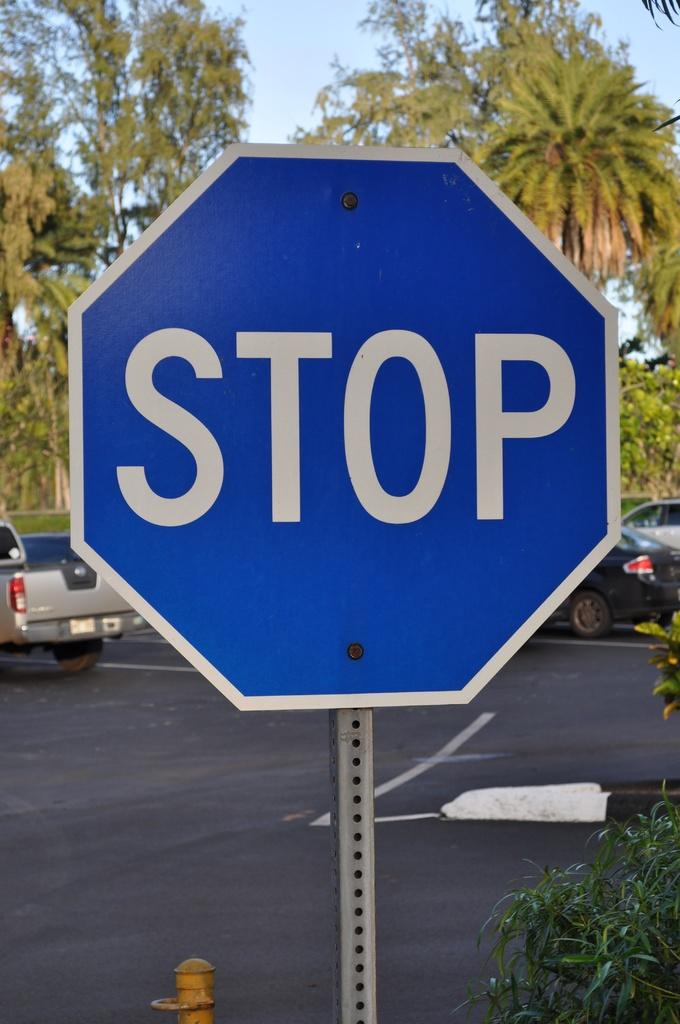<image>
Render a clear and concise summary of the photo. a stop sign that is blue in color outside 